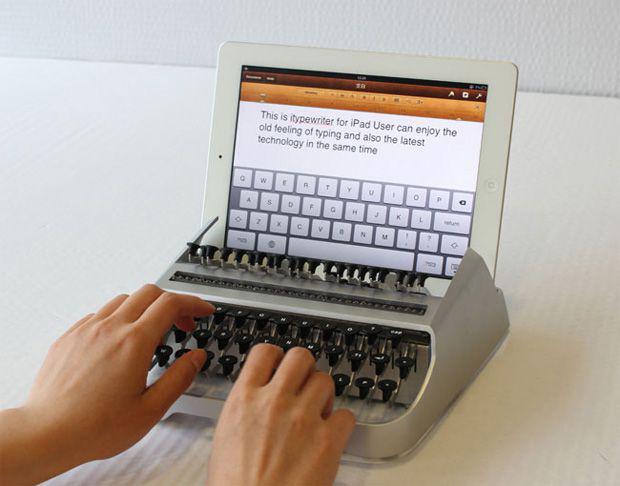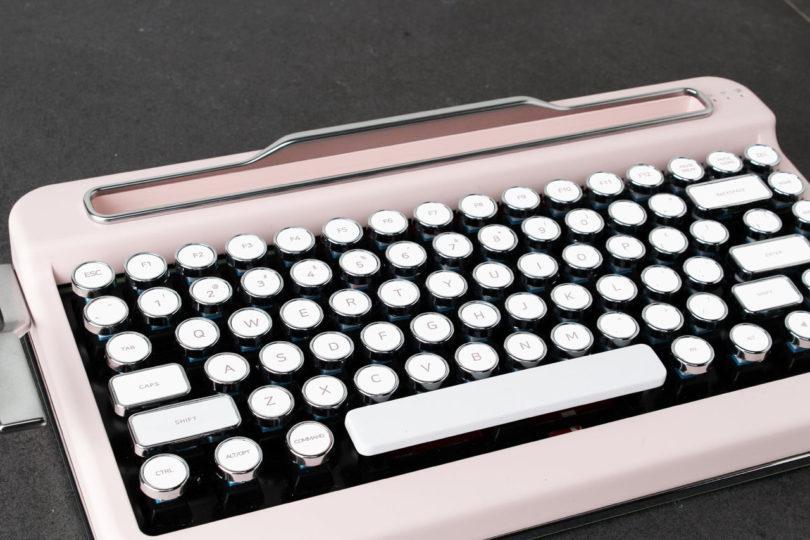The first image is the image on the left, the second image is the image on the right. For the images displayed, is the sentence "One photo includes a pair of human hands." factually correct? Answer yes or no. Yes. The first image is the image on the left, the second image is the image on the right. Analyze the images presented: Is the assertion "One image includes a pair of human hands with one typewriter device." valid? Answer yes or no. Yes. 